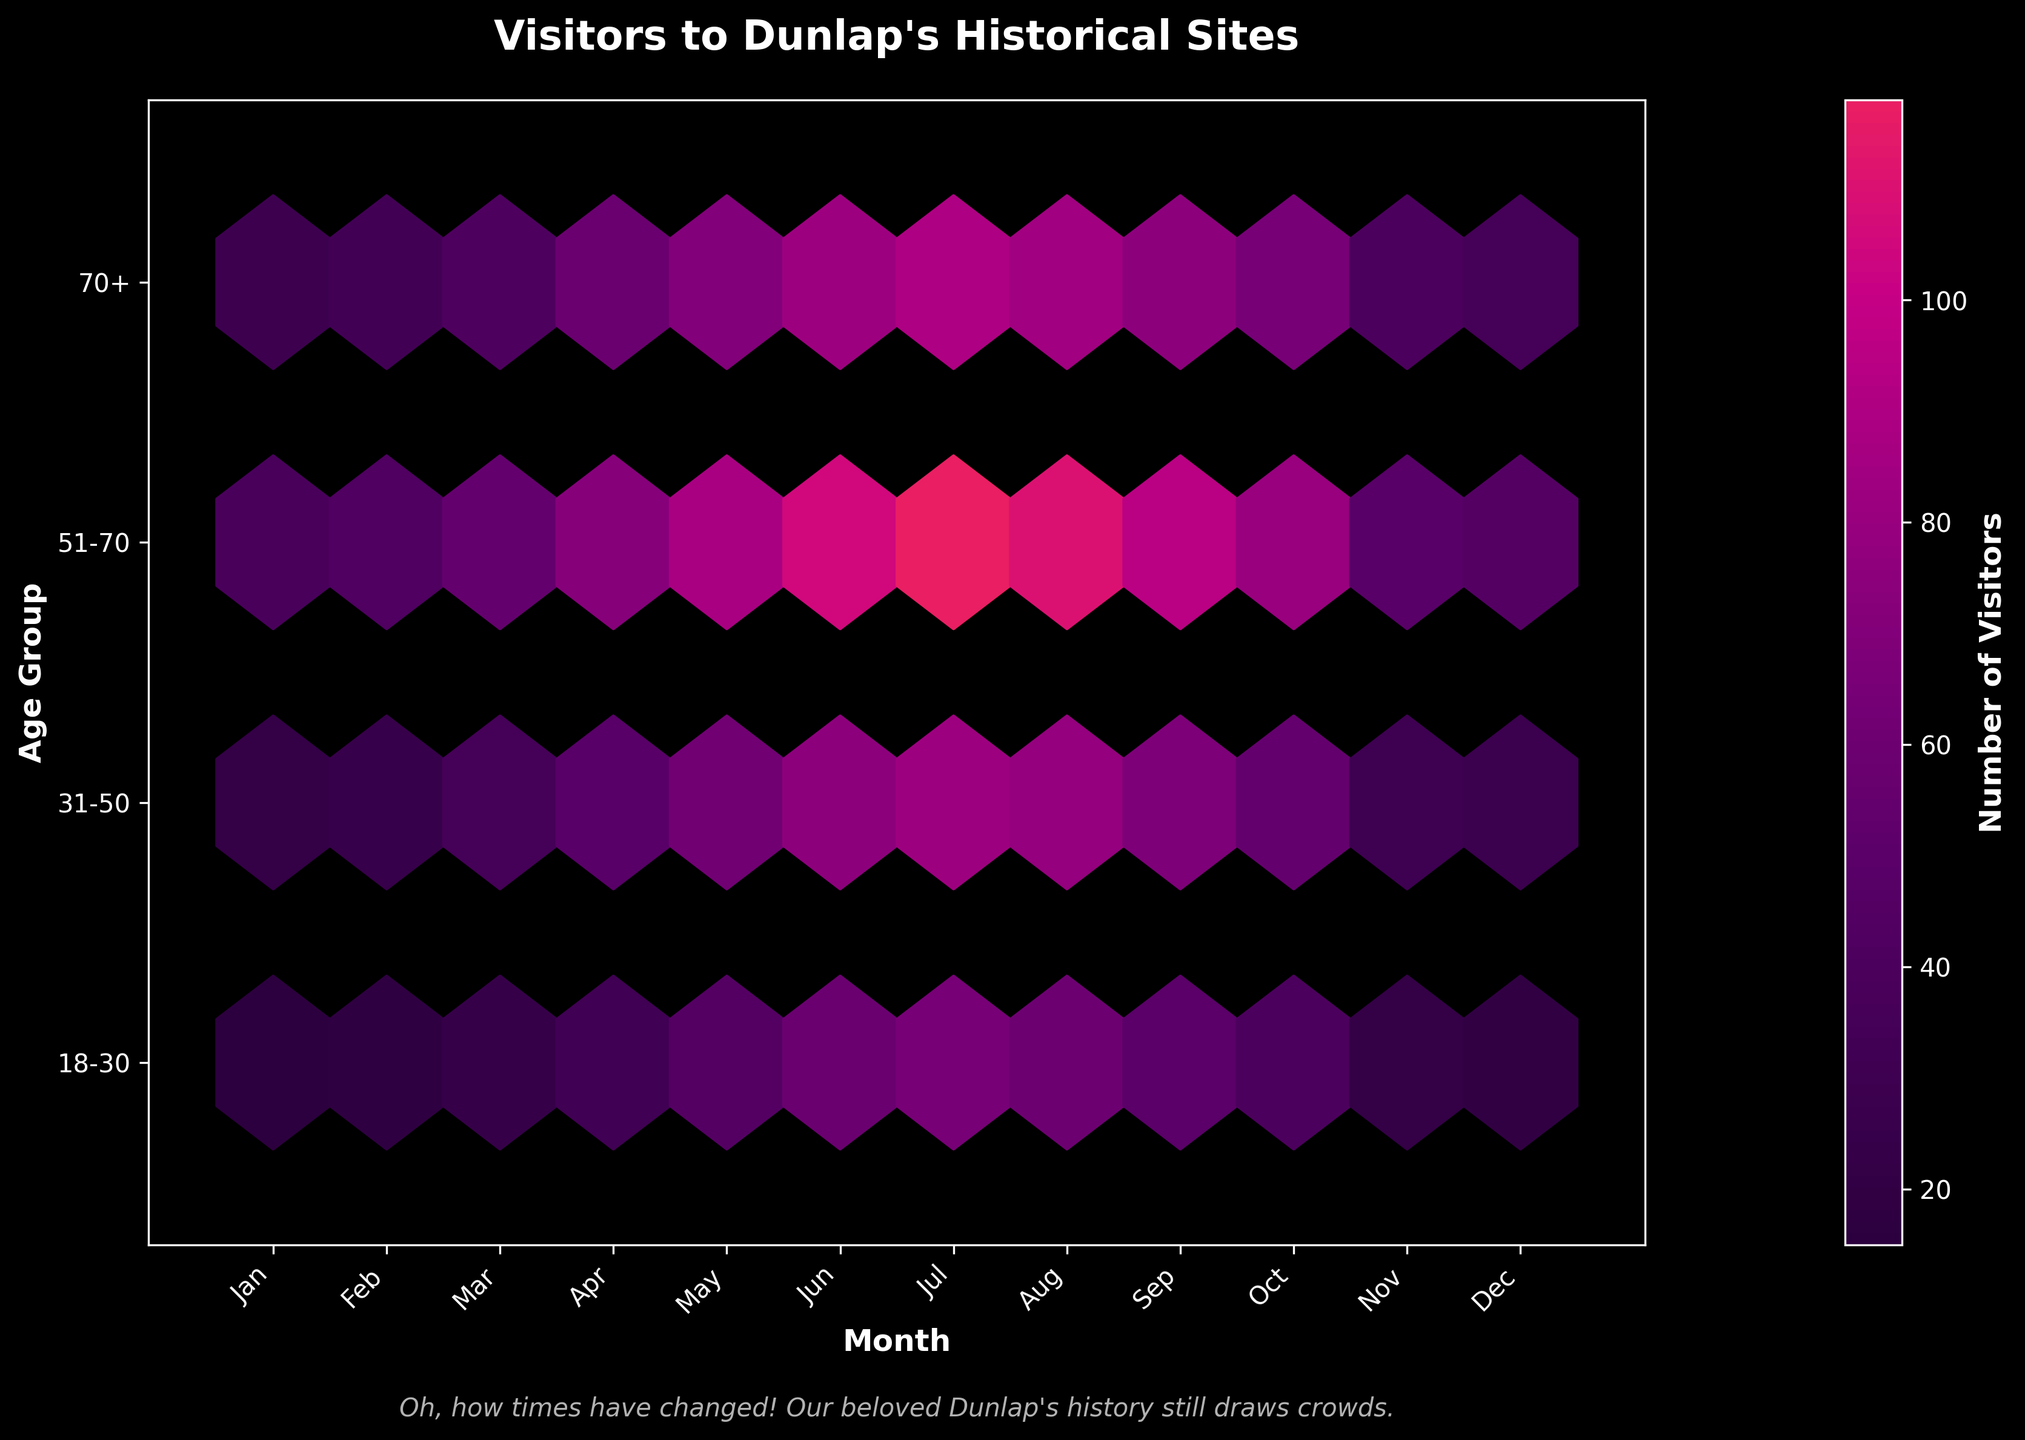What is the title of the figure? The title is located at the top of the plot and summarizes the graph. Here, it indicates what the graph is about.
Answer: Visitors to Dunlap's Historical Sites Which month had the highest number of visitors for the age group 51-70? Identify the highest value in the 'Visitors' axis for the age group 51-70. The hexbin plot shows a brighter color indicating a higher number of visitors.
Answer: July How do visitor numbers change from January to July for the age group 18-30? Observing the hexbin plot, one can see the color gradually getting brighter from January to July, indicating an increase in visitors.
Answer: Increasing Compare the number of visitors in May for the age groups 31-50 and 70+. Which group has more visitors and by how much? Find the hexagons for May for both age groups and compare their color intensities. The hexagon for 31-50 is brighter, indicating more visitors. Subtract the number of visitors for 70+ from 31-50.
Answer: 31-50 has 8 more visitors than 70+ What season has the highest overall visitor count? Use all age groups for this calculation. Sum the visitor counts for each season by adding the visitor numbers of the months within each season: Winter (Dec to Feb), Spring (Mar to May), Summer (Jun to Aug), and Fall (Sep to Nov). The plot reveals higher counts for summer months through color intensities.
Answer: Summer What is the range of visitor numbers across all months for the age group 70+? The range is calculated by finding the maximum and minimum visitor numbers for the age group 70+ and then subtracting the minimum from the maximum. From the hexbin plot, the highest value is in July and the lowest is in January.
Answer: 61 (90 - 29) During which month and for which age group do we see the least number of visitors? Examine the hexbin plot for the month and age group with the darkest color, indicating the lowest number of visitors.
Answer: January, 18-30 Is there any age group that consistently had high visitor numbers throughout the year? Look for a consistent pattern of bright colors across all months for a specific age group on the hexbin plot. The age group 51-70 demonstrates consistently higher visitor numbers.
Answer: 51-70 